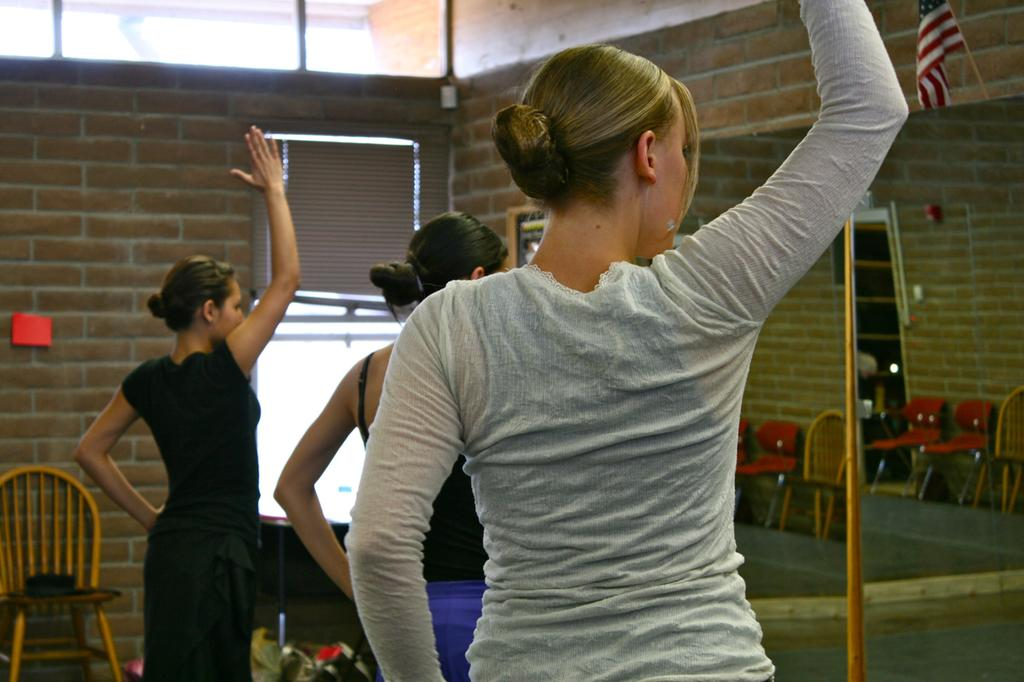How many women are present in the image? There are three women in the image. Where are the women located? The women are standing in a room. What objects can be seen in the room? There is a mirror in the room. What can be seen in the background of the image? There is a wall, a chair, and a flag in the background of the image. Can you tell me how the women are using their thumbs in the image? There is no indication in the image that the women are using their thumbs in any particular way. What type of sail can be seen in the image? There is no sail present in the image; it is a room with three women, a mirror, and a background with a wall, a chair, and a flag. 